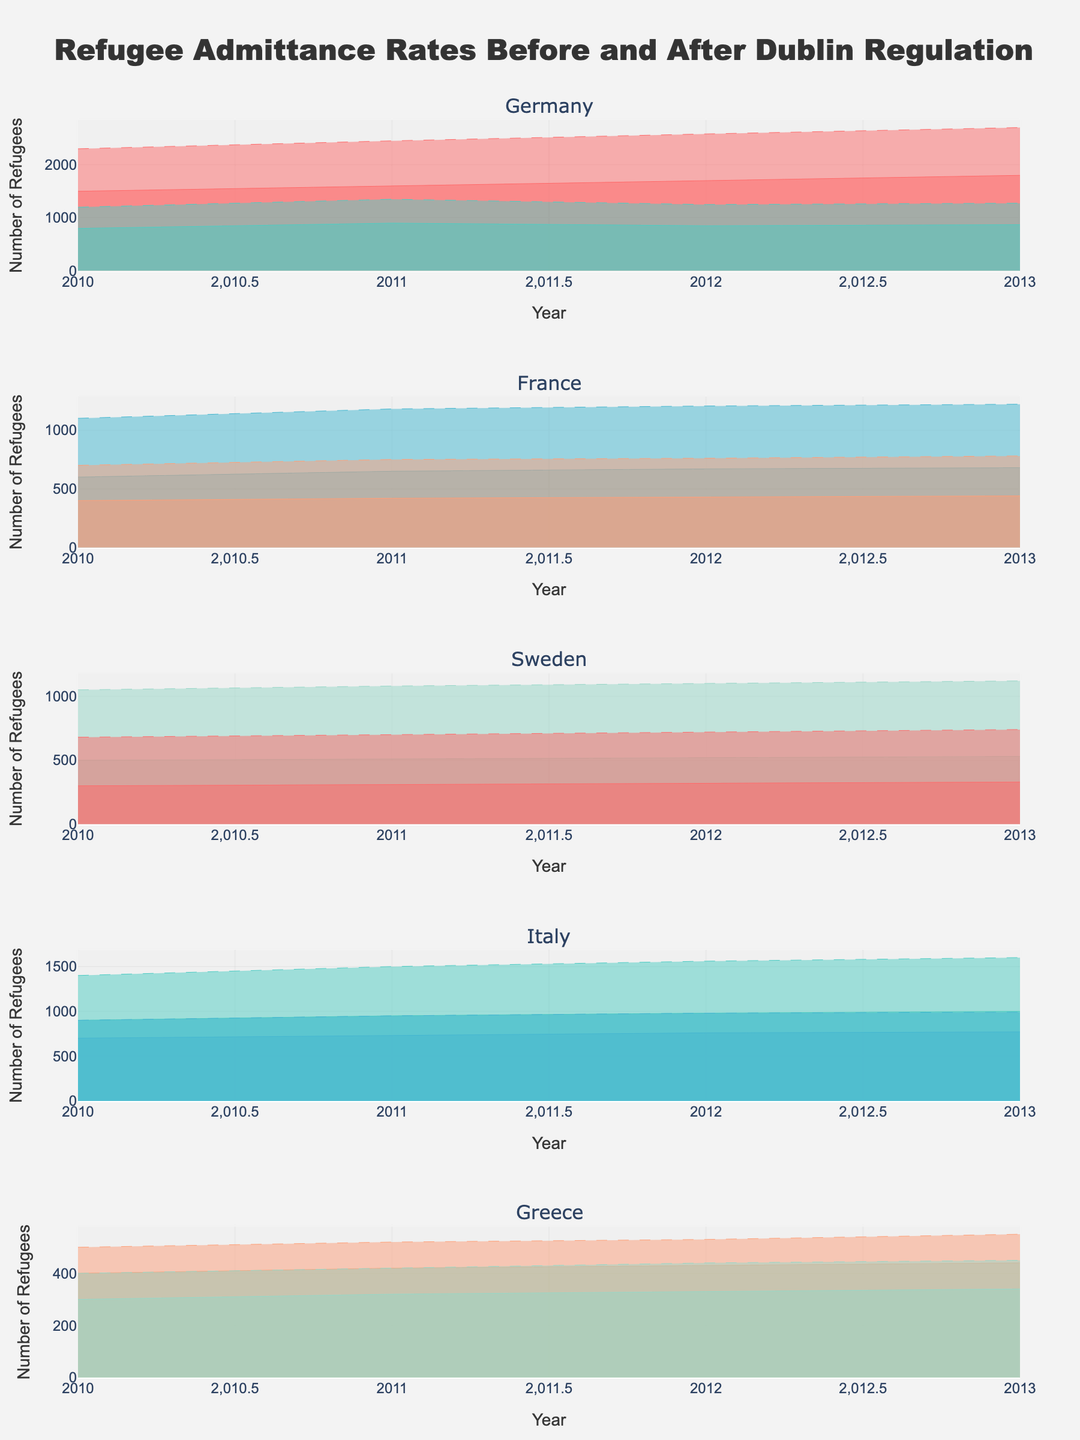What is the title of the figure? The title of the figure is usually found at the top of the plot. In this case, it reads "Refugee Admittance Rates Before and After Dublin Regulation."
Answer: Refugee Admittance Rates Before and After Dublin Regulation What years are covered on the x-axis in the figure? By examining the x-axis of any subplot in the figure, we can see the years range from 2010 to 2013.
Answer: 2010 to 2013 Which origin country of refugees to Germany saw a higher admittance rate after the Dublin Regulation compared to before in 2012? Looking at the subplot for Germany in 2012, we compare the admittance rates of refugees from Syria and Afghanistan. Both have higher admittance rates after the Dublin Regulation, but Syria had a more significant increase (1700 before to 2580 after, while Afghanistan went from 850 before to 1250 after).
Answer: Syria How did the admittance rates for refugees from Sudan to Sweden change from 2010 to 2013 both before and after the Dublin Regulation? In the subplot for Sweden, the area representing Sudan should be examined. Before the Dublin Regulation, the rates increased from 300 in 2010 to 330 in 2013. After the Dublin Regulation, the rates increased more significantly from 680 in 2010 to 740 in 2013.
Answer: Increased in both cases What was the admittance rate for refugees from Iraq to France in 2011 before and after the Dublin Regulation? In the subplot for France, focus on the area representing Iraq in 2011. Before the Dublin Regulation, the admittance rate was 650. After, it was 1180.
Answer: 650 before, 1180 after Which country had the highest admittance rate increase for refugees from Libya after the Dublin Regulation in 2013? Comparing the subplots for each country, Italy's subplot for Libya shows an increase from 1000 before to 1600 after, which is the highest increase.
Answer: Italy What trend do you observe for the admittance rates of refugees from Bangladesh to Greece before and after the Dublin Regulation from 2010 to 2013? In the subplot for Greece, the area representing Bangladesh should be examined. Both before and after the Dublin Regulation, there is a consistent increase in admittance rates from 300 before to 340 before and 400 after to 450 after.
Answer: Consistent increase Which country had the smallest increase in refugee admittance rates after the Dublin Regulation when considering refugees from Afghanistan? By examining the subplots for each country and focusing on Afghanistan, Germany shows an increase from 800 to 1200, 900 to 1350, 850 to 1250, and 870 to 1275, respectively. This is the only country represented for Afghanistan, so it must have the smallest increase.
Answer: Germany 